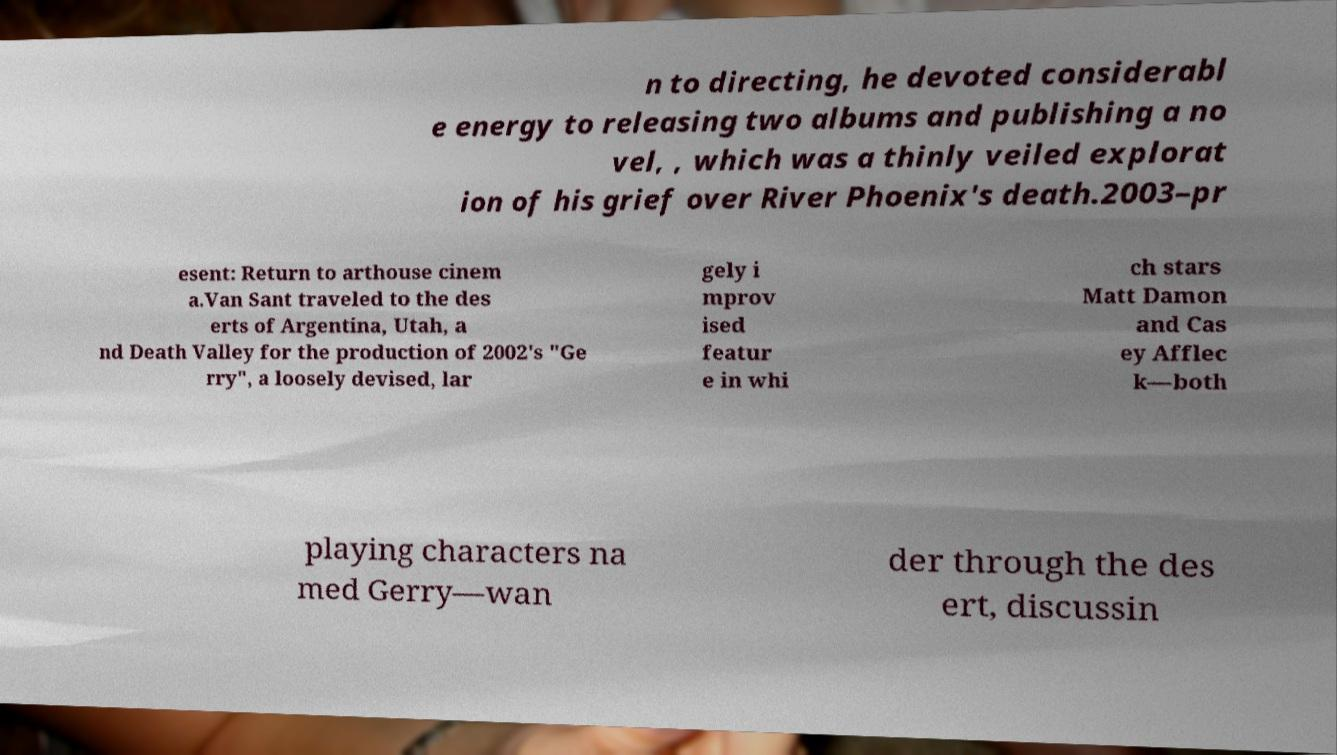Please read and relay the text visible in this image. What does it say? n to directing, he devoted considerabl e energy to releasing two albums and publishing a no vel, , which was a thinly veiled explorat ion of his grief over River Phoenix's death.2003–pr esent: Return to arthouse cinem a.Van Sant traveled to the des erts of Argentina, Utah, a nd Death Valley for the production of 2002's "Ge rry", a loosely devised, lar gely i mprov ised featur e in whi ch stars Matt Damon and Cas ey Afflec k—both playing characters na med Gerry—wan der through the des ert, discussin 